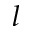<formula> <loc_0><loc_0><loc_500><loc_500>l</formula> 